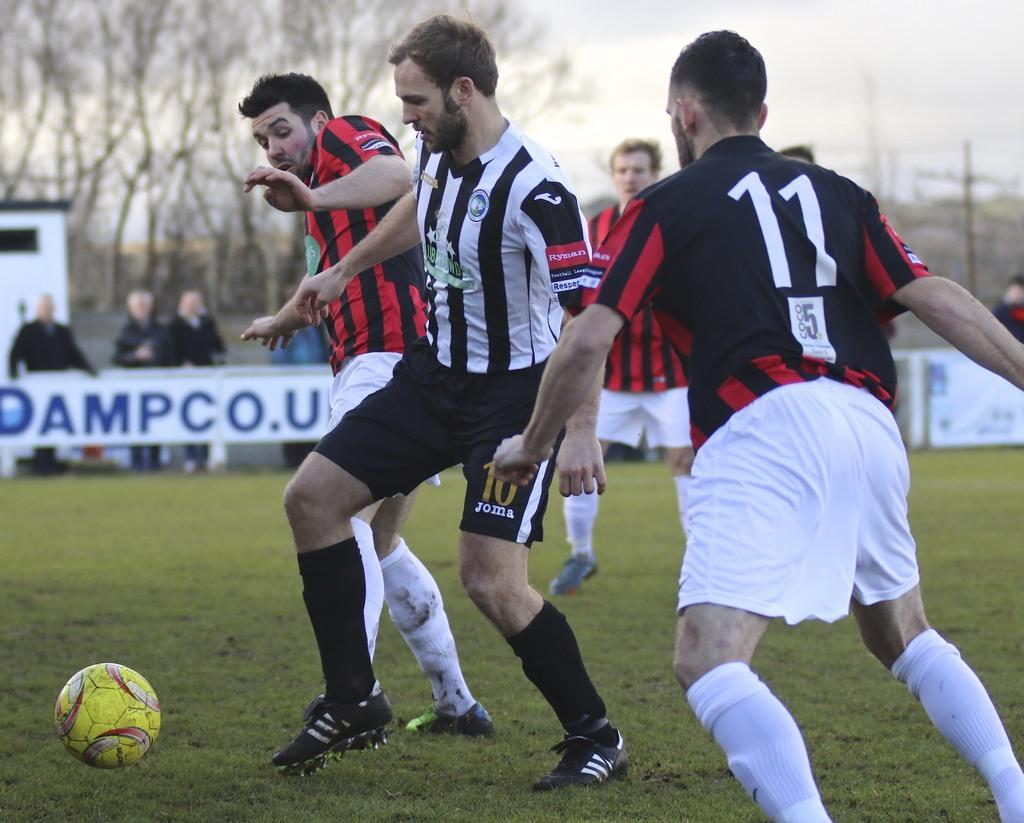<image>
Give a short and clear explanation of the subsequent image. Player number 11 is running toward the player with the soccer ball. 